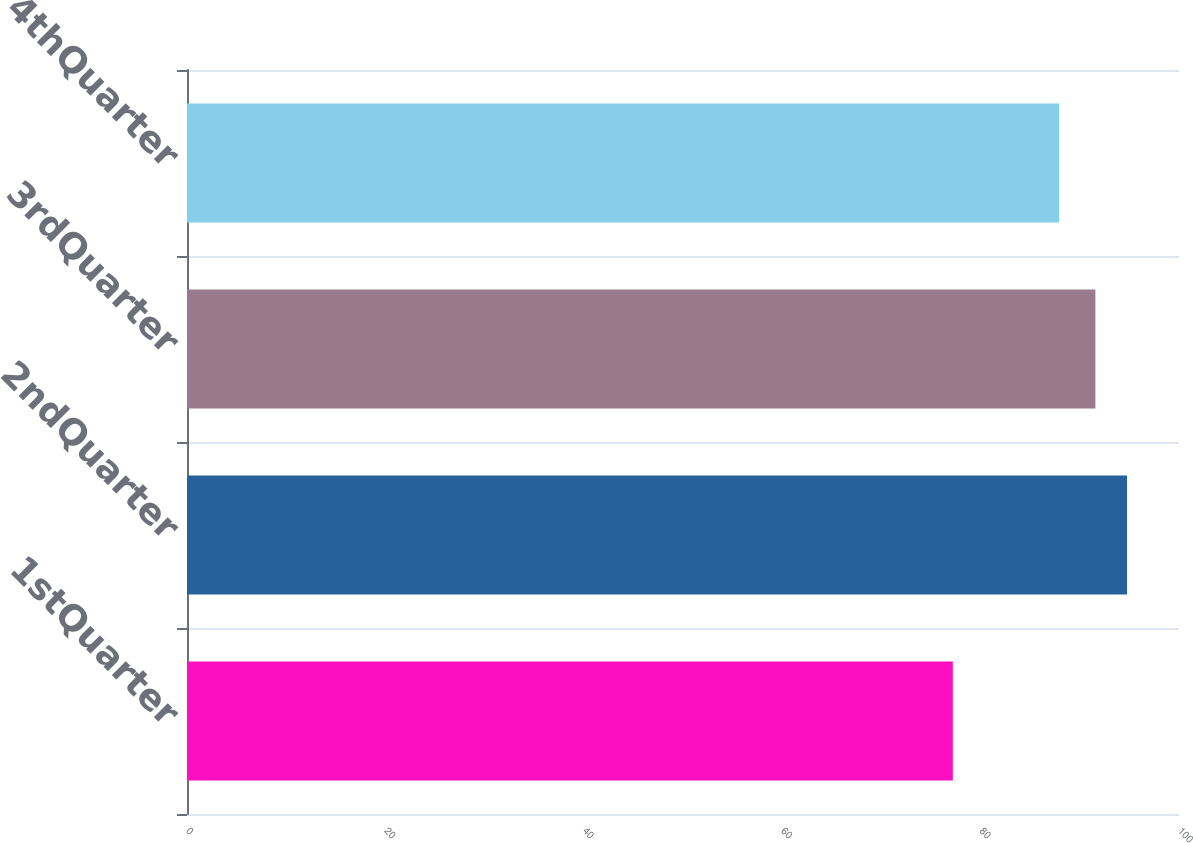Convert chart. <chart><loc_0><loc_0><loc_500><loc_500><bar_chart><fcel>1stQuarter<fcel>2ndQuarter<fcel>3rdQuarter<fcel>4thQuarter<nl><fcel>77.2<fcel>94.76<fcel>91.57<fcel>87.92<nl></chart> 